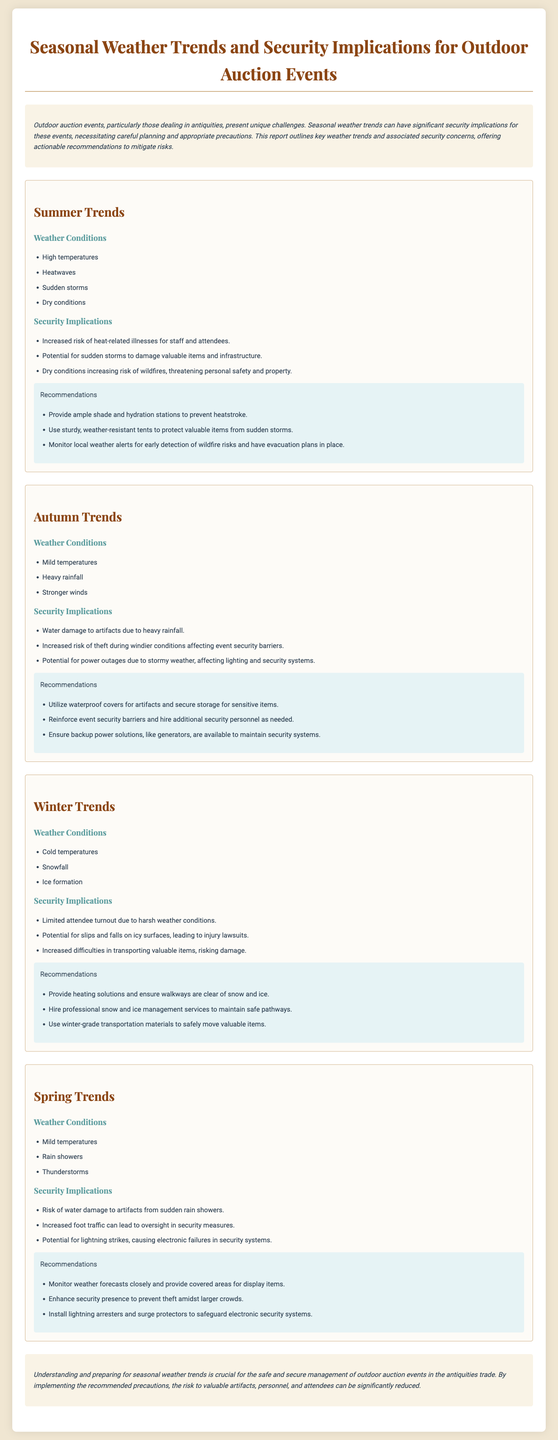What are the weather conditions for summer? The weather conditions for summer include high temperatures, heatwaves, sudden storms, and dry conditions.
Answer: High temperatures, heatwaves, sudden storms, dry conditions What security implication is related to rainfall in autumn? Water damage to artifacts is a security implication related to heavy rainfall in autumn.
Answer: Water damage to artifacts What is a recommendation for managing heat-related illnesses in summer? Providing ample shade and hydration stations is a recommendation for managing heat-related illnesses in summer.
Answer: Ample shade and hydration stations Which season has a risk of theft due to wind? Autumn has an increased risk of theft during windier conditions affecting event security barriers.
Answer: Autumn What are the three weather conditions listed for winter? The three weather conditions listed for winter are cold temperatures, snowfall, and ice formation.
Answer: Cold temperatures, snowfall, ice formation What is the recommendation for handling water damage risks in spring? The recommendation for handling water damage risks in spring is to monitor weather forecasts closely and provide covered areas for display items.
Answer: Monitor weather forecasts closely and provide covered areas How does limited attendee turnout affect winter events? Limited attendee turnout can be attributed to harsh winter weather conditions, which may decrease participation.
Answer: Limited attendee turnout What is one of the security implications of thunderstorms in spring? One of the security implications of thunderstorms in spring is the potential for lightning strikes causing electronic failures in security systems.
Answer: Potential for lightning strikes What is the overall conclusion regarding weather trends? Understanding and preparing for seasonal weather trends is crucial for the safe and secure management of outdoor auction events in the antiquities trade.
Answer: Understanding and preparing for seasonal weather trends is crucial 